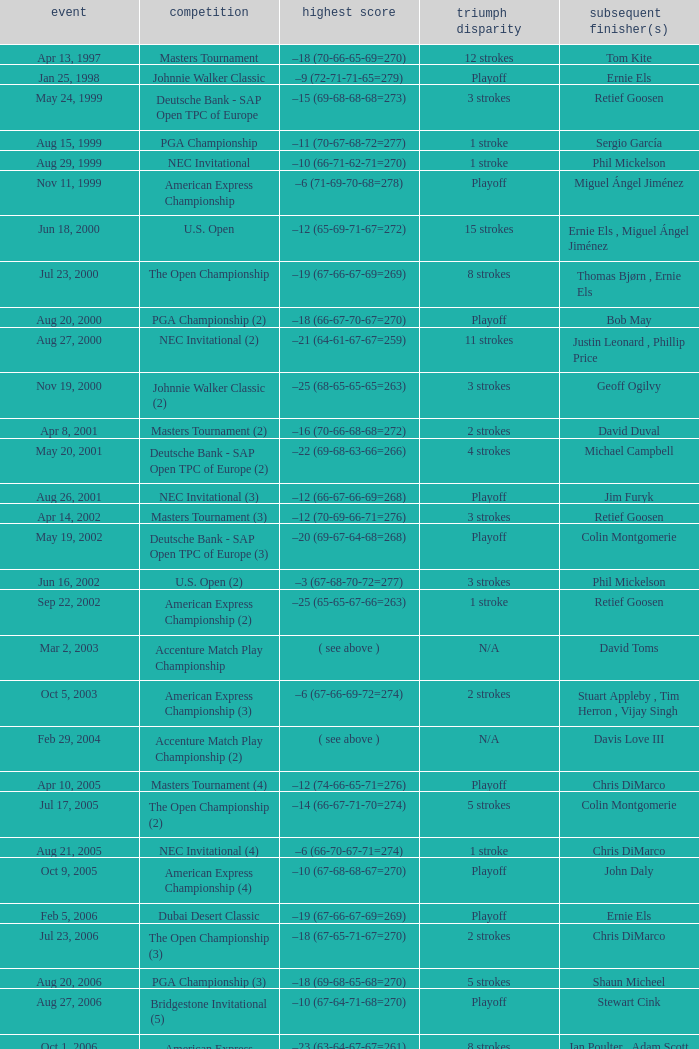Who is Runner(s)-up that has a Date of may 24, 1999? Retief Goosen. 